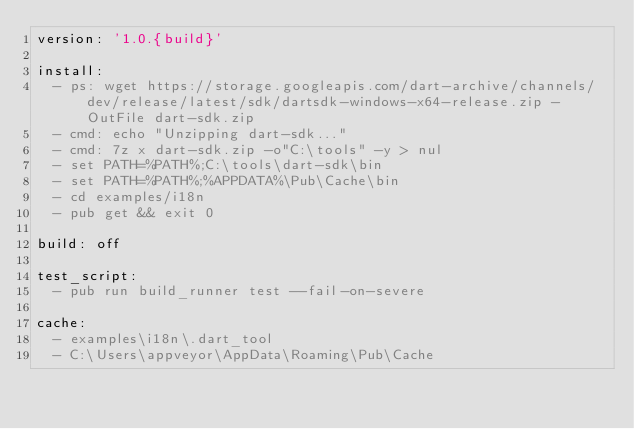Convert code to text. <code><loc_0><loc_0><loc_500><loc_500><_YAML_>version: '1.0.{build}'

install:
  - ps: wget https://storage.googleapis.com/dart-archive/channels/dev/release/latest/sdk/dartsdk-windows-x64-release.zip -OutFile dart-sdk.zip
  - cmd: echo "Unzipping dart-sdk..."
  - cmd: 7z x dart-sdk.zip -o"C:\tools" -y > nul
  - set PATH=%PATH%;C:\tools\dart-sdk\bin
  - set PATH=%PATH%;%APPDATA%\Pub\Cache\bin
  - cd examples/i18n
  - pub get && exit 0

build: off

test_script:
  - pub run build_runner test --fail-on-severe

cache:
  - examples\i18n\.dart_tool
  - C:\Users\appveyor\AppData\Roaming\Pub\Cache
</code> 